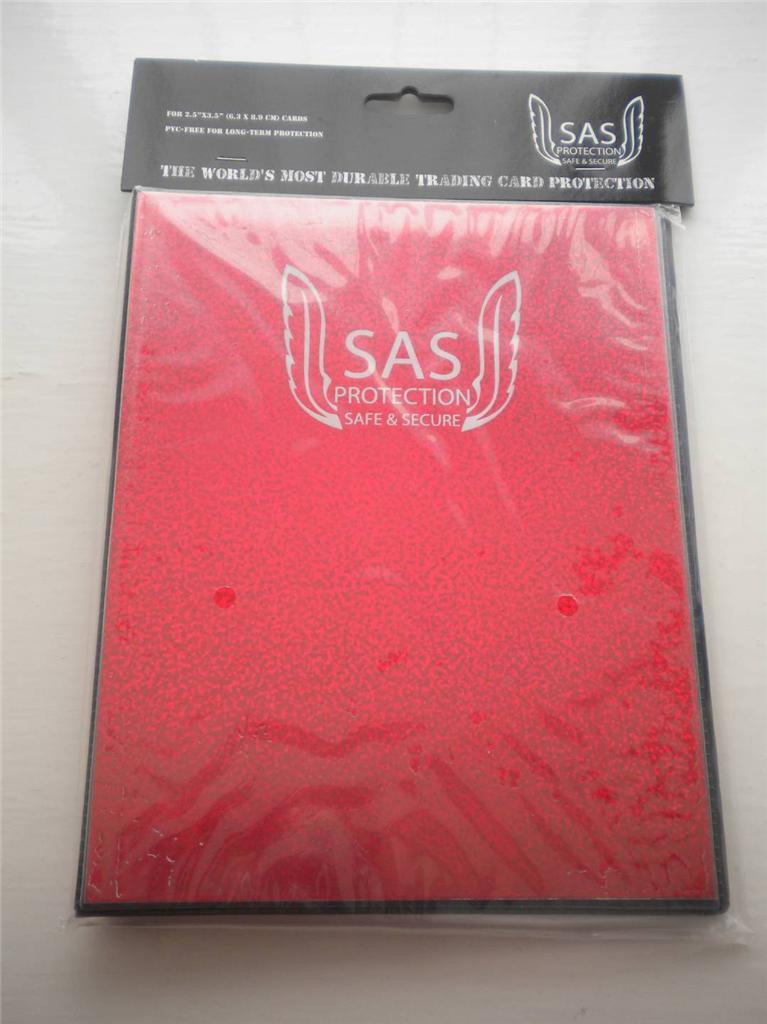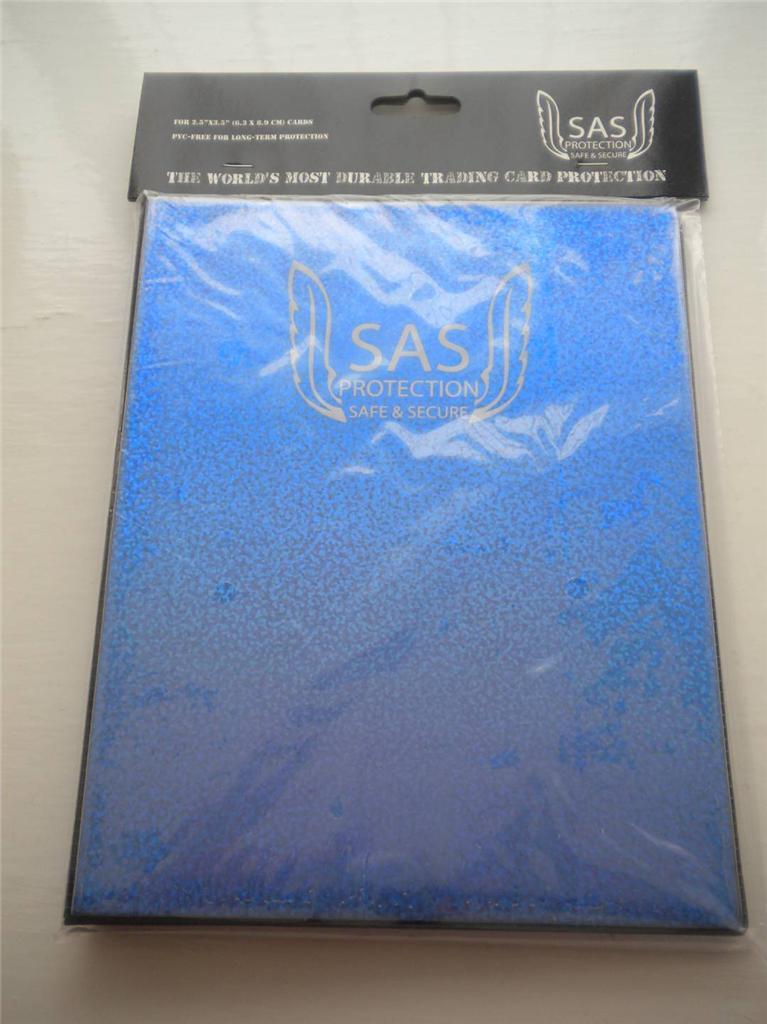The first image is the image on the left, the second image is the image on the right. Considering the images on both sides, is "There is one red and one blue folder." valid? Answer yes or no. Yes. 